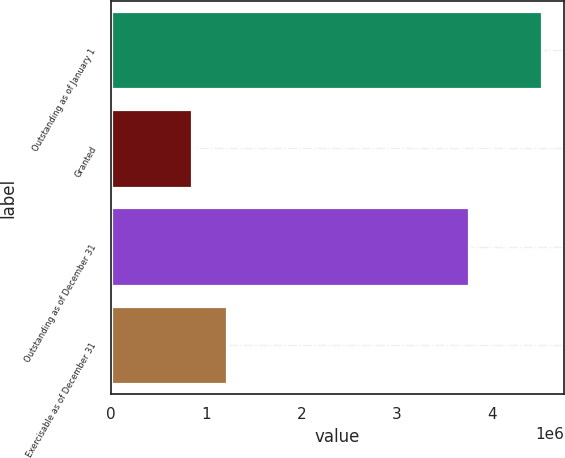Convert chart to OTSL. <chart><loc_0><loc_0><loc_500><loc_500><bar_chart><fcel>Outstanding as of January 1<fcel>Granted<fcel>Outstanding as of December 31<fcel>Exercisable as of December 31<nl><fcel>4.53098e+06<fcel>845440<fcel>3.75795e+06<fcel>1.21399e+06<nl></chart> 